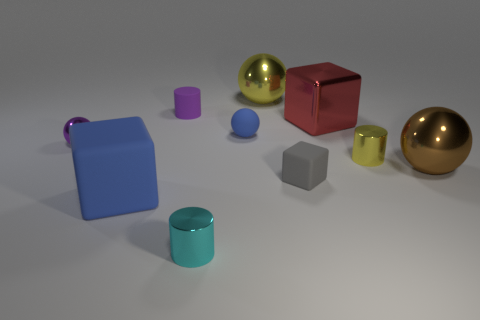Is there anything else that has the same material as the gray block?
Give a very brief answer. Yes. There is a metal cylinder that is in front of the gray rubber block; is it the same size as the big red metal cube?
Provide a succinct answer. No. Do the blue matte thing that is behind the big brown metal sphere and the purple shiny thing have the same shape?
Your answer should be very brief. Yes. What number of objects are big red shiny objects or things that are behind the red thing?
Ensure brevity in your answer.  3. Is the number of brown things less than the number of large cubes?
Offer a very short reply. Yes. Is the number of big yellow shiny things greater than the number of big purple rubber things?
Provide a succinct answer. Yes. How many other things are the same material as the red block?
Your answer should be very brief. 5. What number of blue matte things are right of the blue thing that is to the left of the shiny cylinder that is on the left side of the small gray matte cube?
Provide a short and direct response. 1. How many rubber things are blue spheres or yellow things?
Your answer should be very brief. 1. How big is the metallic thing behind the small rubber thing that is left of the cyan metallic thing?
Provide a succinct answer. Large. 